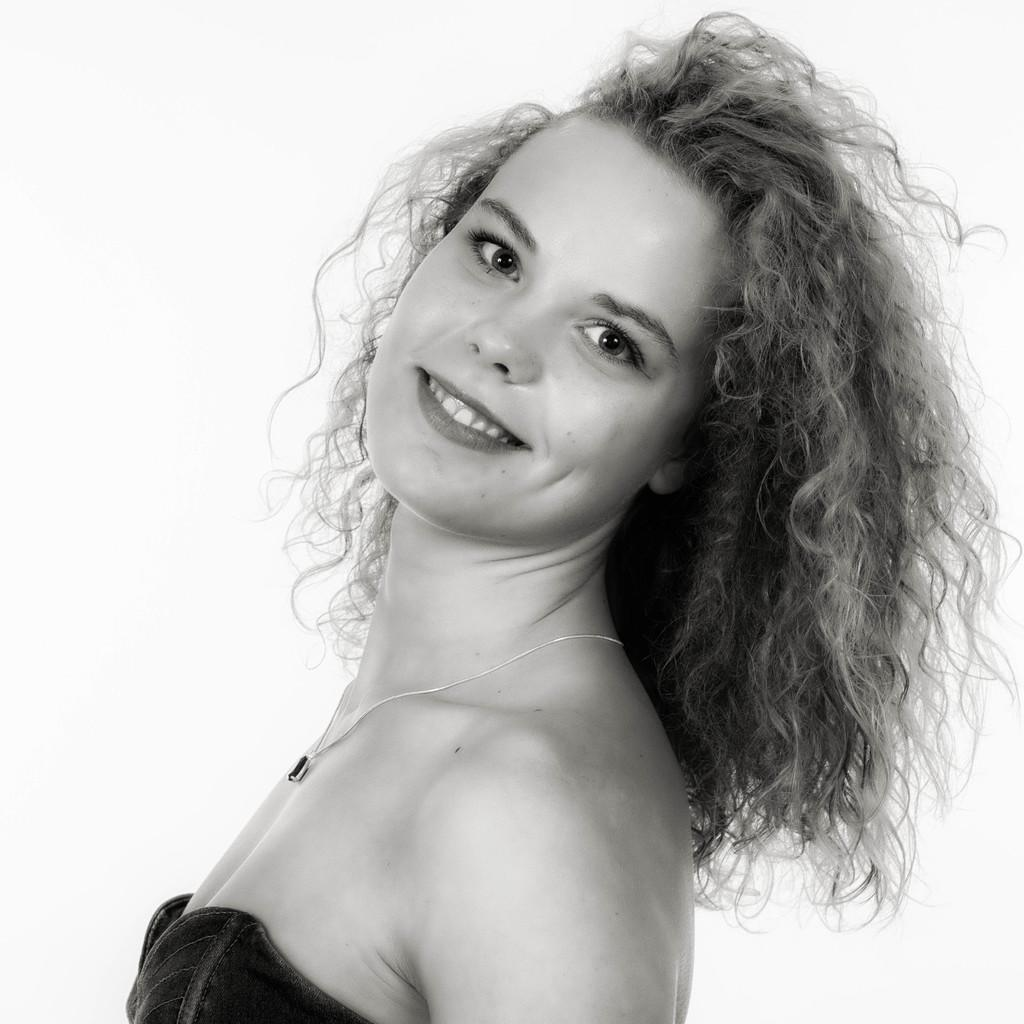What is the main subject of the image? There is a person standing in the image. Can you describe the person's attire? The person is wearing a chain. What is the color scheme of the image? The image is in black and white. What type of thread is the person using to communicate with their insect friends in the image? There is no thread or insects present in the image, and the person is not communicating with any friends. 